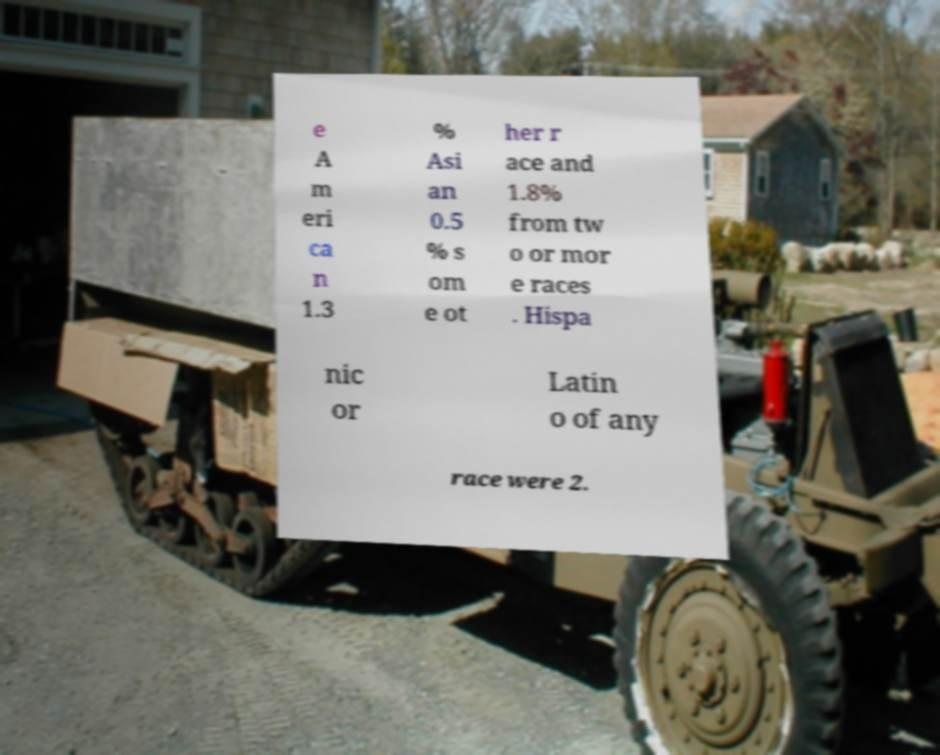Could you extract and type out the text from this image? e A m eri ca n 1.3 % Asi an 0.5 % s om e ot her r ace and 1.8% from tw o or mor e races . Hispa nic or Latin o of any race were 2. 